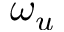Convert formula to latex. <formula><loc_0><loc_0><loc_500><loc_500>\omega _ { u }</formula> 